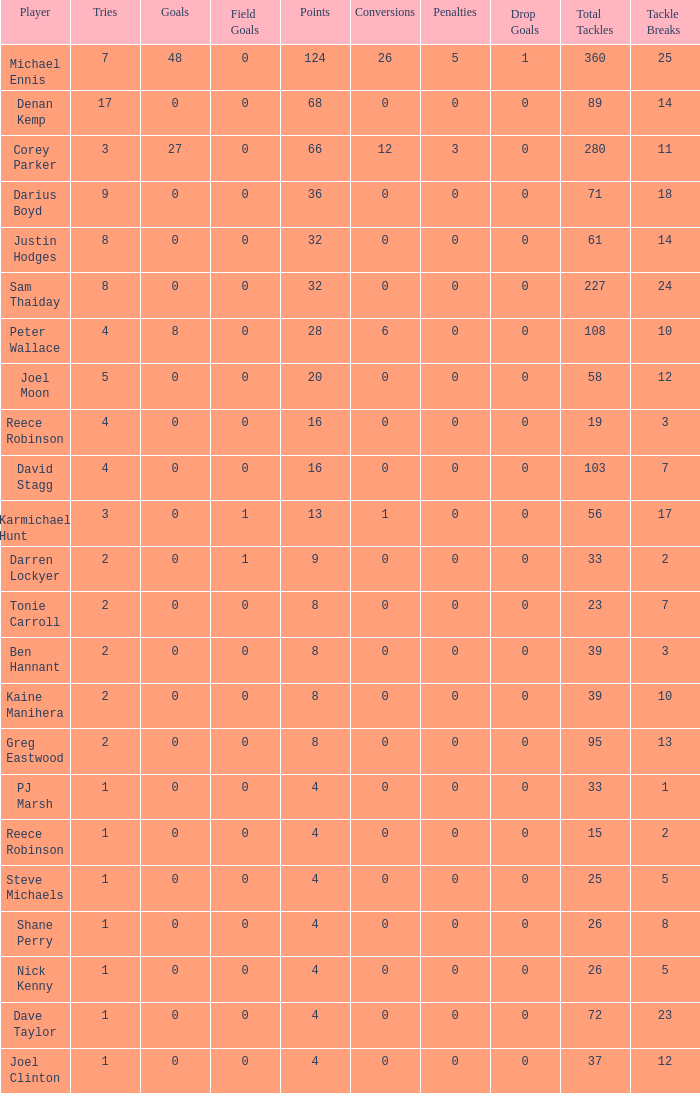What is the total number of field goals of Denan Kemp, who has more than 4 tries, more than 32 points, and 0 goals? 1.0. 